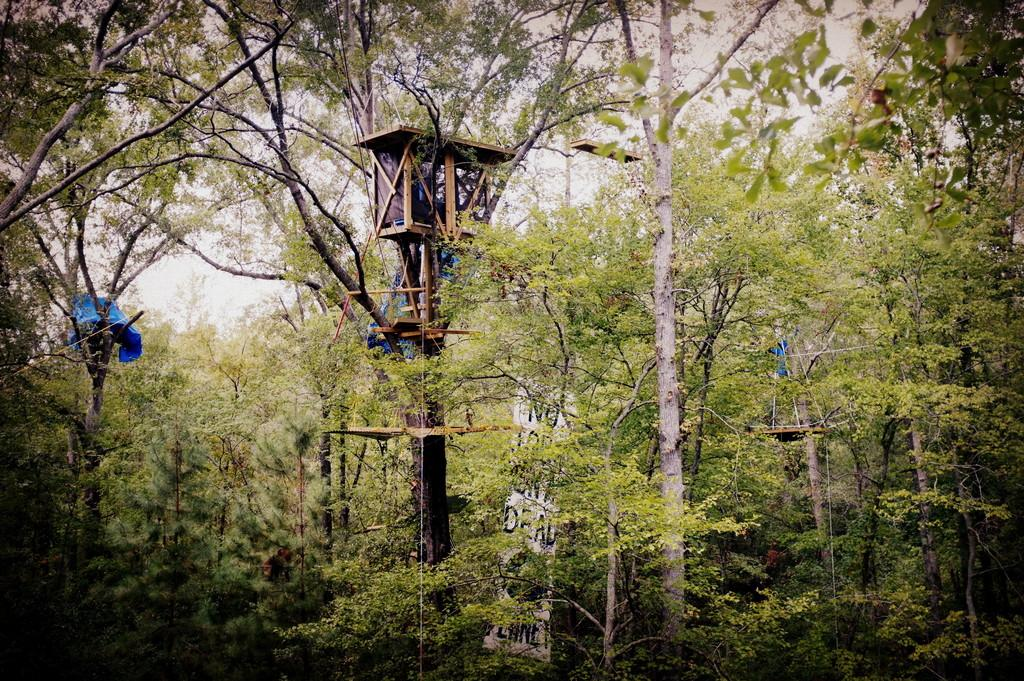What type of natural environment is depicted in the image? There is a forest in the image. What can be found within the forest? The forest contains many plants and trees. Is there any man-made structure visible in the image? Yes, there is a pole with a small shed on top of it. What can be seen in the sky through the trees? The sky is partially visible through the trees. How many hooks are hanging from the trees in the image? There are no hooks visible in the image; it features a forest with plants, trees, and a pole with a small shed on top of it. 